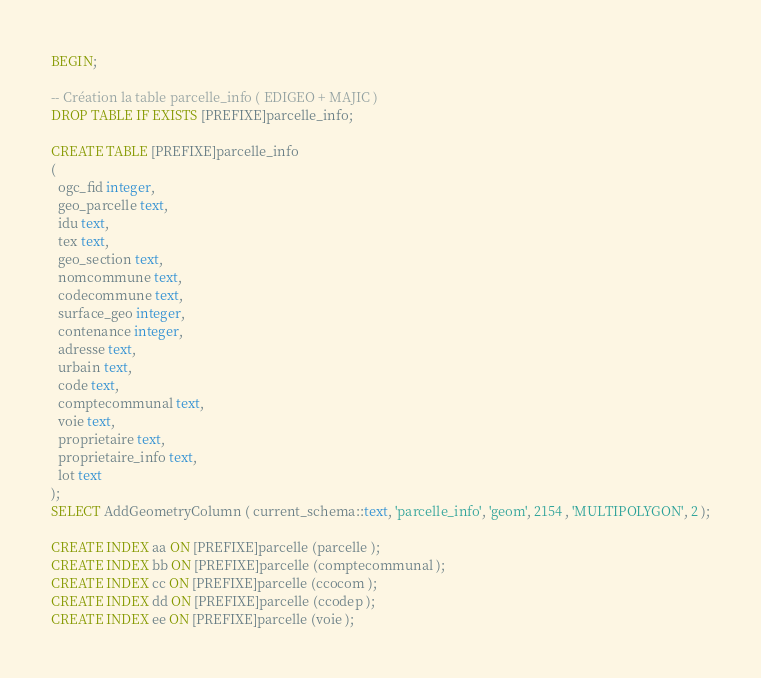Convert code to text. <code><loc_0><loc_0><loc_500><loc_500><_SQL_>BEGIN;

-- Création la table parcelle_info ( EDIGEO + MAJIC )
DROP TABLE IF EXISTS [PREFIXE]parcelle_info;

CREATE TABLE [PREFIXE]parcelle_info
(
  ogc_fid integer,
  geo_parcelle text,
  idu text,
  tex text,
  geo_section text,
  nomcommune text,
  codecommune text,
  surface_geo integer,
  contenance integer,
  adresse text,
  urbain text,
  code text,
  comptecommunal text,
  voie text,
  proprietaire text,
  proprietaire_info text,
  lot text
);
SELECT AddGeometryColumn ( current_schema::text, 'parcelle_info', 'geom', 2154 , 'MULTIPOLYGON', 2 );

CREATE INDEX aa ON [PREFIXE]parcelle (parcelle );
CREATE INDEX bb ON [PREFIXE]parcelle (comptecommunal );
CREATE INDEX cc ON [PREFIXE]parcelle (ccocom );
CREATE INDEX dd ON [PREFIXE]parcelle (ccodep );
CREATE INDEX ee ON [PREFIXE]parcelle (voie );</code> 